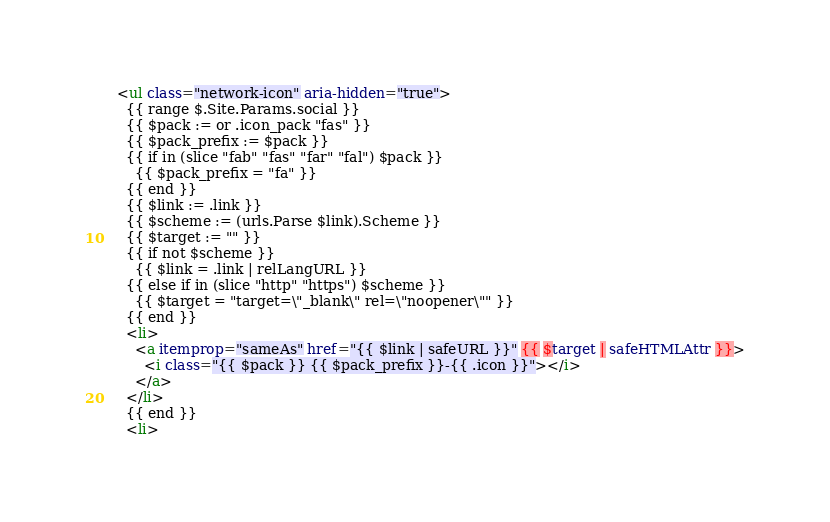Convert code to text. <code><loc_0><loc_0><loc_500><loc_500><_HTML_>    <ul class="network-icon" aria-hidden="true">
      {{ range $.Site.Params.social }}
      {{ $pack := or .icon_pack "fas" }}
      {{ $pack_prefix := $pack }}
      {{ if in (slice "fab" "fas" "far" "fal") $pack }}
        {{ $pack_prefix = "fa" }}
      {{ end }}
      {{ $link := .link }}
      {{ $scheme := (urls.Parse $link).Scheme }}
      {{ $target := "" }}
      {{ if not $scheme }}
        {{ $link = .link | relLangURL }}
      {{ else if in (slice "http" "https") $scheme }}
        {{ $target = "target=\"_blank\" rel=\"noopener\"" }}
      {{ end }}
      <li>
        <a itemprop="sameAs" href="{{ $link | safeURL }}" {{ $target | safeHTMLAttr }}>
          <i class="{{ $pack }} {{ $pack_prefix }}-{{ .icon }}"></i>
        </a>
      </li>
      {{ end }}
      <li></code> 